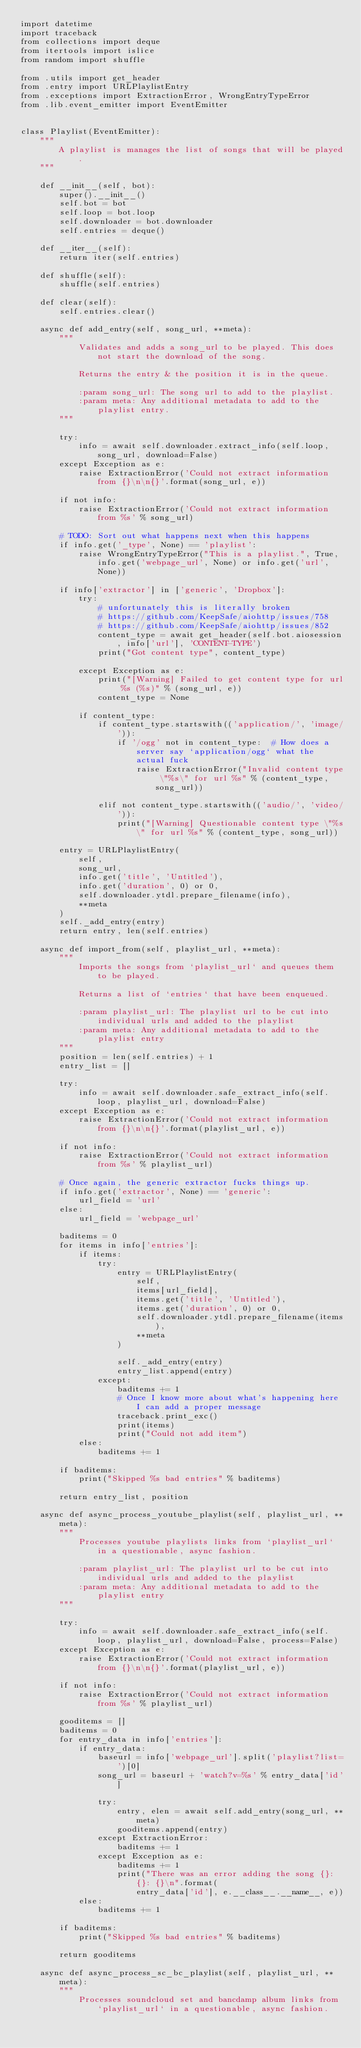<code> <loc_0><loc_0><loc_500><loc_500><_Python_>import datetime
import traceback
from collections import deque
from itertools import islice
from random import shuffle

from .utils import get_header
from .entry import URLPlaylistEntry
from .exceptions import ExtractionError, WrongEntryTypeError
from .lib.event_emitter import EventEmitter


class Playlist(EventEmitter):
    """
        A playlist is manages the list of songs that will be played.
    """

    def __init__(self, bot):
        super().__init__()
        self.bot = bot
        self.loop = bot.loop
        self.downloader = bot.downloader
        self.entries = deque()

    def __iter__(self):
        return iter(self.entries)

    def shuffle(self):
        shuffle(self.entries)

    def clear(self):
        self.entries.clear()

    async def add_entry(self, song_url, **meta):
        """
            Validates and adds a song_url to be played. This does not start the download of the song.

            Returns the entry & the position it is in the queue.

            :param song_url: The song url to add to the playlist.
            :param meta: Any additional metadata to add to the playlist entry.
        """

        try:
            info = await self.downloader.extract_info(self.loop, song_url, download=False)
        except Exception as e:
            raise ExtractionError('Could not extract information from {}\n\n{}'.format(song_url, e))

        if not info:
            raise ExtractionError('Could not extract information from %s' % song_url)

        # TODO: Sort out what happens next when this happens
        if info.get('_type', None) == 'playlist':
            raise WrongEntryTypeError("This is a playlist.", True, info.get('webpage_url', None) or info.get('url', None))

        if info['extractor'] in ['generic', 'Dropbox']:
            try:
                # unfortunately this is literally broken
                # https://github.com/KeepSafe/aiohttp/issues/758
                # https://github.com/KeepSafe/aiohttp/issues/852
                content_type = await get_header(self.bot.aiosession, info['url'], 'CONTENT-TYPE')
                print("Got content type", content_type)

            except Exception as e:
                print("[Warning] Failed to get content type for url %s (%s)" % (song_url, e))
                content_type = None

            if content_type:
                if content_type.startswith(('application/', 'image/')):
                    if '/ogg' not in content_type:  # How does a server say `application/ogg` what the actual fuck
                        raise ExtractionError("Invalid content type \"%s\" for url %s" % (content_type, song_url))

                elif not content_type.startswith(('audio/', 'video/')):
                    print("[Warning] Questionable content type \"%s\" for url %s" % (content_type, song_url))

        entry = URLPlaylistEntry(
            self,
            song_url,
            info.get('title', 'Untitled'),
            info.get('duration', 0) or 0,
            self.downloader.ytdl.prepare_filename(info),
            **meta
        )
        self._add_entry(entry)
        return entry, len(self.entries)

    async def import_from(self, playlist_url, **meta):
        """
            Imports the songs from `playlist_url` and queues them to be played.

            Returns a list of `entries` that have been enqueued.

            :param playlist_url: The playlist url to be cut into individual urls and added to the playlist
            :param meta: Any additional metadata to add to the playlist entry
        """
        position = len(self.entries) + 1
        entry_list = []

        try:
            info = await self.downloader.safe_extract_info(self.loop, playlist_url, download=False)
        except Exception as e:
            raise ExtractionError('Could not extract information from {}\n\n{}'.format(playlist_url, e))

        if not info:
            raise ExtractionError('Could not extract information from %s' % playlist_url)

        # Once again, the generic extractor fucks things up.
        if info.get('extractor', None) == 'generic':
            url_field = 'url'
        else:
            url_field = 'webpage_url'

        baditems = 0
        for items in info['entries']:
            if items:
                try:
                    entry = URLPlaylistEntry(
                        self,
                        items[url_field],
                        items.get('title', 'Untitled'),
                        items.get('duration', 0) or 0,
                        self.downloader.ytdl.prepare_filename(items),
                        **meta
                    )

                    self._add_entry(entry)
                    entry_list.append(entry)
                except:
                    baditems += 1
                    # Once I know more about what's happening here I can add a proper message
                    traceback.print_exc()
                    print(items)
                    print("Could not add item")
            else:
                baditems += 1

        if baditems:
            print("Skipped %s bad entries" % baditems)

        return entry_list, position

    async def async_process_youtube_playlist(self, playlist_url, **meta):
        """
            Processes youtube playlists links from `playlist_url` in a questionable, async fashion.

            :param playlist_url: The playlist url to be cut into individual urls and added to the playlist
            :param meta: Any additional metadata to add to the playlist entry
        """

        try:
            info = await self.downloader.safe_extract_info(self.loop, playlist_url, download=False, process=False)
        except Exception as e:
            raise ExtractionError('Could not extract information from {}\n\n{}'.format(playlist_url, e))

        if not info:
            raise ExtractionError('Could not extract information from %s' % playlist_url)

        gooditems = []
        baditems = 0
        for entry_data in info['entries']:
            if entry_data:
                baseurl = info['webpage_url'].split('playlist?list=')[0]
                song_url = baseurl + 'watch?v=%s' % entry_data['id']

                try:
                    entry, elen = await self.add_entry(song_url, **meta)
                    gooditems.append(entry)
                except ExtractionError:
                    baditems += 1
                except Exception as e:
                    baditems += 1
                    print("There was an error adding the song {}: {}: {}\n".format(
                        entry_data['id'], e.__class__.__name__, e))
            else:
                baditems += 1

        if baditems:
            print("Skipped %s bad entries" % baditems)

        return gooditems

    async def async_process_sc_bc_playlist(self, playlist_url, **meta):
        """
            Processes soundcloud set and bancdamp album links from `playlist_url` in a questionable, async fashion.
</code> 